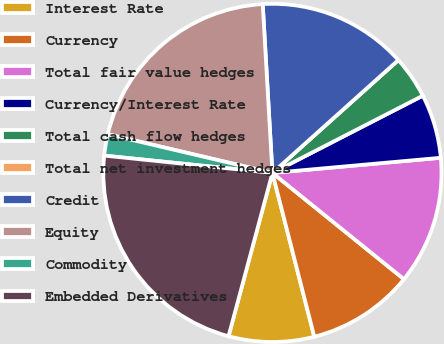Convert chart. <chart><loc_0><loc_0><loc_500><loc_500><pie_chart><fcel>Interest Rate<fcel>Currency<fcel>Total fair value hedges<fcel>Currency/Interest Rate<fcel>Total cash flow hedges<fcel>Total net investment hedges<fcel>Credit<fcel>Equity<fcel>Commodity<fcel>Embedded Derivatives<nl><fcel>8.16%<fcel>10.2%<fcel>12.24%<fcel>6.12%<fcel>4.08%<fcel>0.0%<fcel>14.28%<fcel>20.41%<fcel>2.04%<fcel>22.45%<nl></chart> 